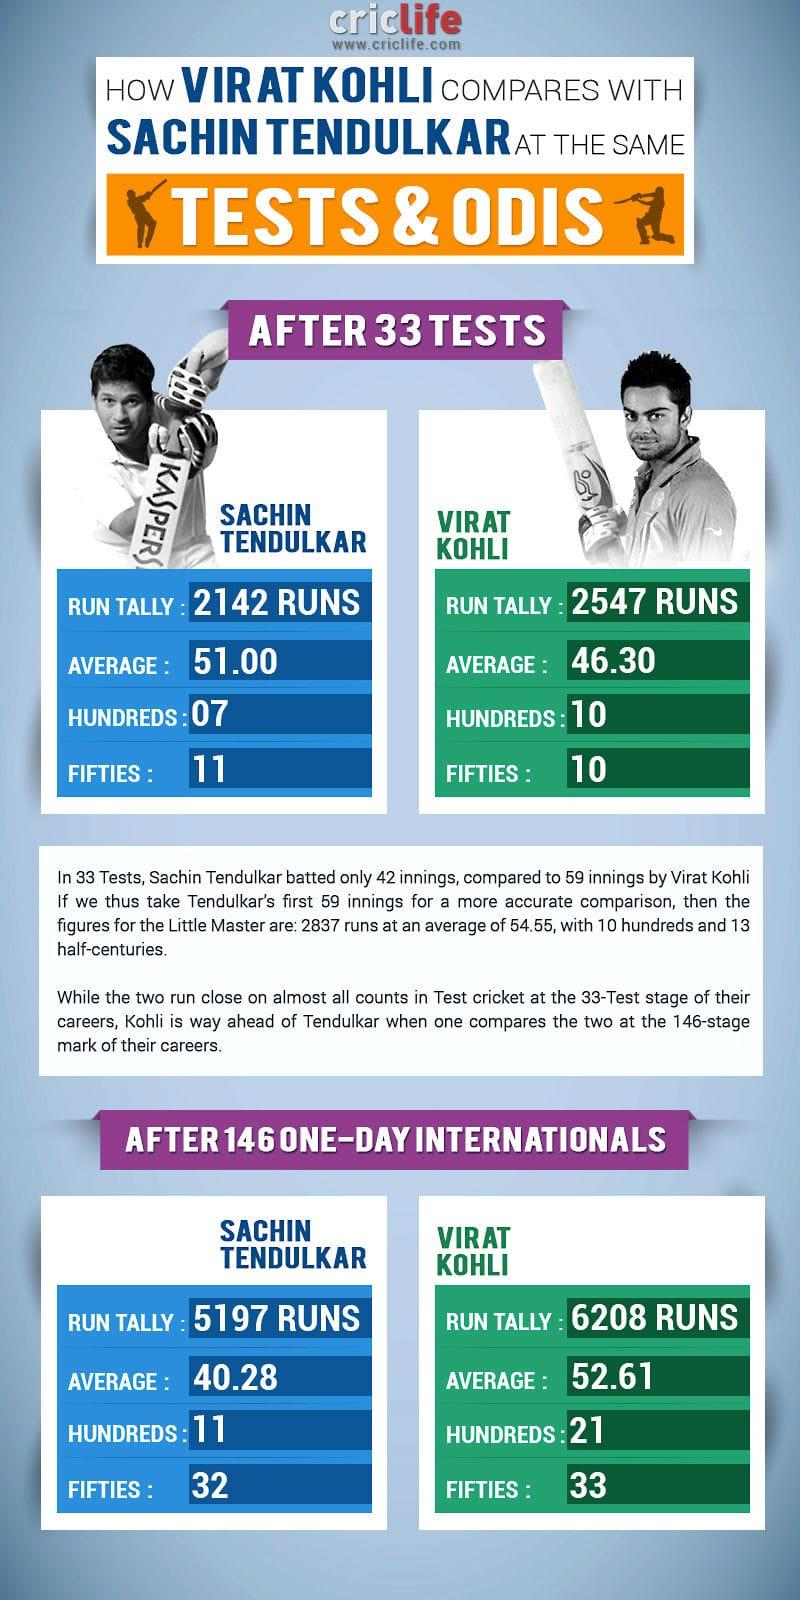Specify some key components in this picture. In 33 tests, Sachin and Kohli scored a combined total of 21 fifties. Sachin and Kohli, together, scored a total of 32 hundreds in 146 one-day internationals. Sachin and Kohli, together, have scored a total of 17 hundreds in 33 tests. In the 146th one-day international match, Sachin and Kohli together scored 65 half-centuries. 